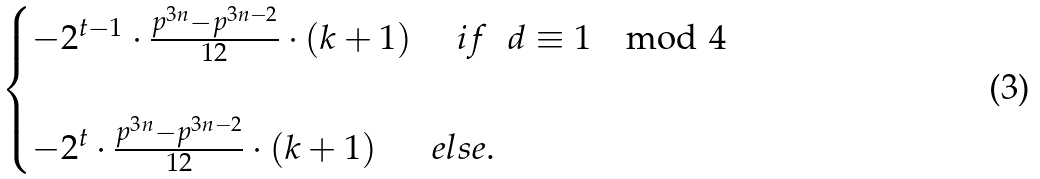<formula> <loc_0><loc_0><loc_500><loc_500>\begin{cases} - 2 ^ { t - 1 } \cdot \frac { p ^ { 3 n } - p ^ { 3 n - 2 } } { 1 2 } \cdot ( k + 1 ) \quad \ i f \ \ d \equiv 1 \mod 4 \\ \\ - 2 ^ { t } \cdot \frac { p ^ { 3 n } - p ^ { 3 n - 2 } } { 1 2 } \cdot ( k + 1 ) \quad \ \ e l s e . \end{cases}</formula> 